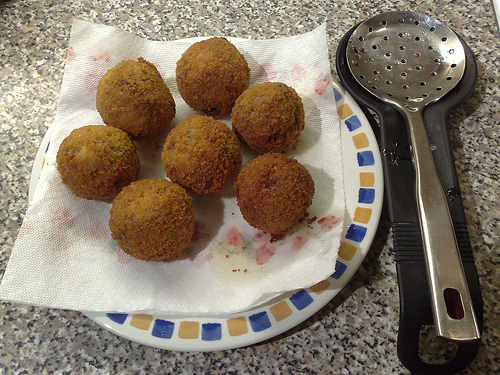<image>
Is the tissue under the food? Yes. The tissue is positioned underneath the food, with the food above it in the vertical space. Is there a napkin under the ball? Yes. The napkin is positioned underneath the ball, with the ball above it in the vertical space. 